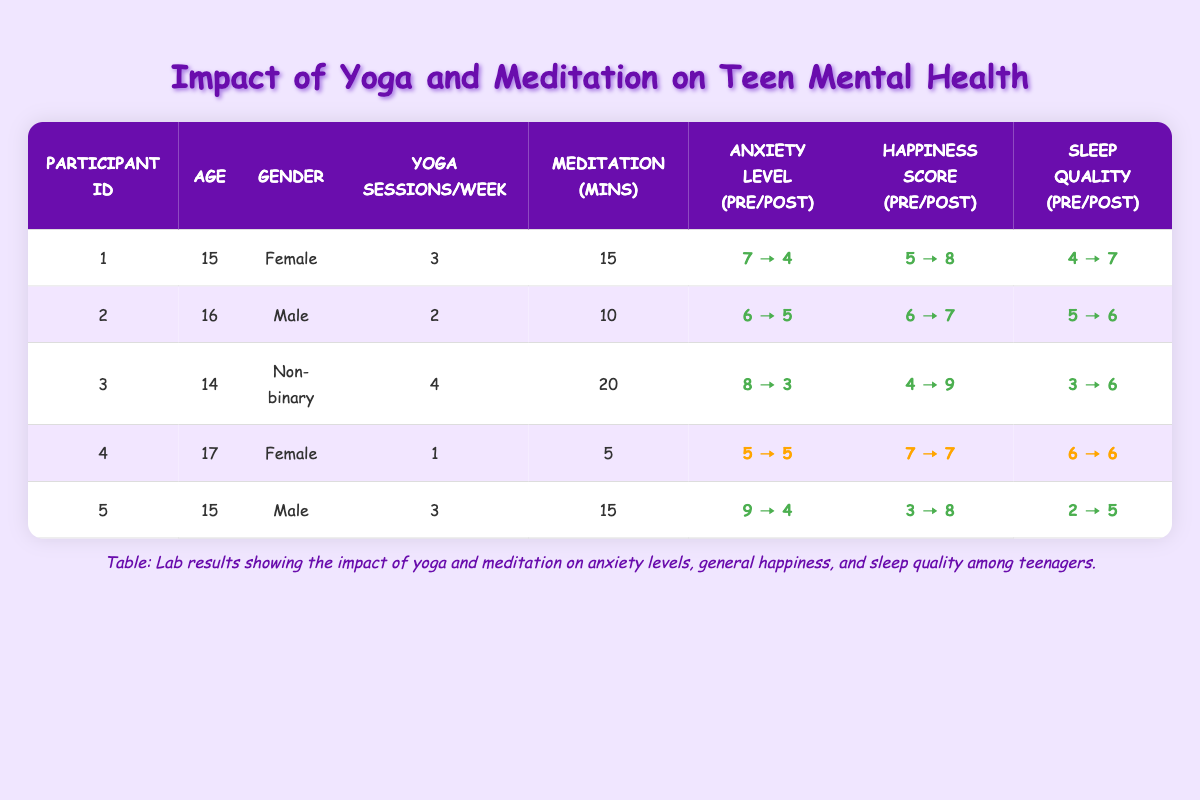What is the average anxiety level pre-intervention for all participants? To find the average anxiety level pre-intervention, we sum the pre-anxiety levels of all participants: 7 + 6 + 8 + 5 + 9 = 35. Then, we divide by the number of participants (5): 35 / 5 = 7.
Answer: 7 Which participant showed the greatest improvement in sleep quality score? To determine which participant had the greatest improvement in sleep quality score, we need to calculate the difference between pre and post values: Participant 1: 4 → 7 (improvement of 3), Participant 2: 5 → 6 (improvement of 1), Participant 3: 3 → 6 (improvement of 3), Participant 4: 6 → 6 (no change), Participant 5: 2 → 5 (improvement of 3). Participants 1, 3, and 5 all improved by 3.
Answer: Participant 1, Participant 3, and Participant 5 had the greatest improvement Did any participant's anxiety level remain the same before and after the intervention? Looking at the anxiety levels pre and post, Participant 4 has an anxiety level of 5 both before and after the intervention, indicating no change.
Answer: Yes What was the total number of yoga sessions attended by all participants in a week? Summing the yoga sessions per week for each participant gives us: 3 + 2 + 4 + 1 + 3 = 13 sessions per week for all participants combined.
Answer: 13 Which participant had the highest general happiness score post-intervention? The post-intervention scores for general happiness are: Participant 1: 8, Participant 2: 7, Participant 3: 9, Participant 4: 7, Participant 5: 8. Therefore, Participant 3 had the highest score of 9.
Answer: Participant 3 What is the change in general happiness score for Participant 5? For Participant 5, the general happiness score changed from 3 before the intervention to 8 after, resulting in an improvement calculation of 8 - 3 = 5.
Answer: 5 Which gender had the highest average improvement in anxiety levels? We will calculate the average improvement for each gender by comparing the pre and post levels: For Female (Participants 1 and 4): (7-4 + 5-5)/2 = 1. Participant 2 (Male): (6-5)/1 = 1. Participant 5 (Male): (9-4)/1 = 5. Non-binary (Participant 3): (8-3)/1 = 5. Total average improvement: Females = 1, Males = 3, Non-binary = 5. The Non-binary participant had the highest improvement.
Answer: Non-binary Which participant had the lowest sleep quality score before the intervention? Reviewing the sleep quality scores before the intervention: Participant 1: 4, Participant 2: 5, Participant 3: 3, Participant 4: 6, Participant 5: 2. The lowest score is from Participant 5, with a score of 2.
Answer: Participant 5 